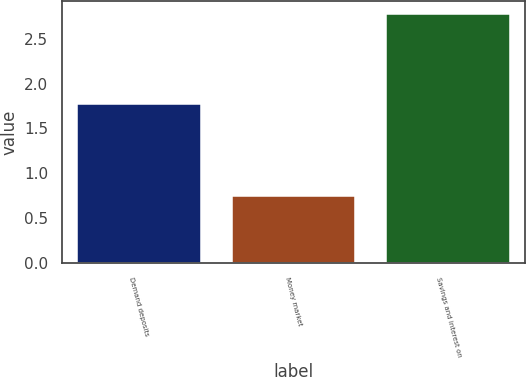Convert chart to OTSL. <chart><loc_0><loc_0><loc_500><loc_500><bar_chart><fcel>Demand deposits<fcel>Money market<fcel>Savings and interest on<nl><fcel>1.77<fcel>0.74<fcel>2.78<nl></chart> 